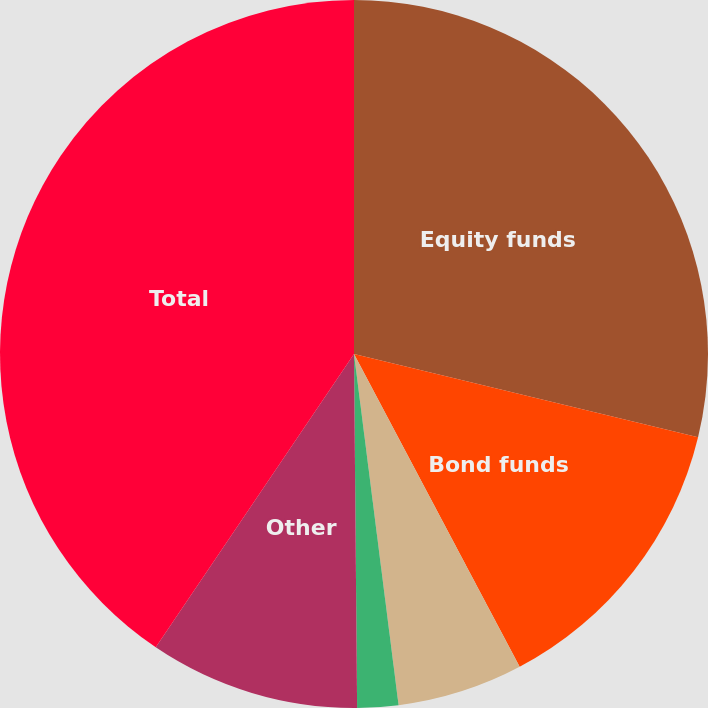<chart> <loc_0><loc_0><loc_500><loc_500><pie_chart><fcel>Equity funds<fcel>Bond funds<fcel>Balanced funds<fcel>Money market funds<fcel>Other<fcel>Total<nl><fcel>28.78%<fcel>13.47%<fcel>5.74%<fcel>1.87%<fcel>9.6%<fcel>40.54%<nl></chart> 